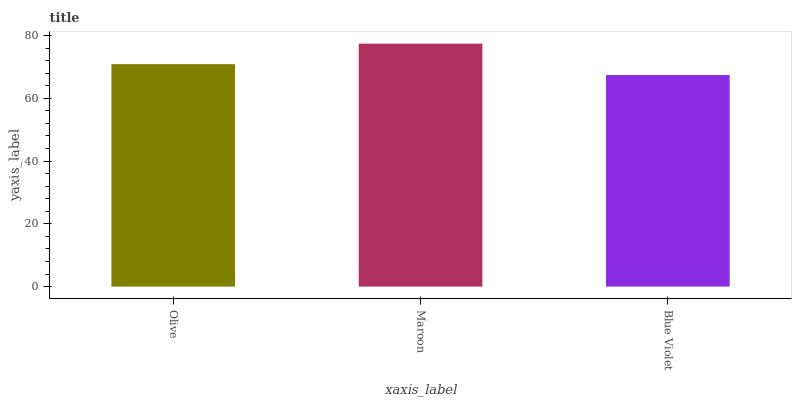Is Blue Violet the minimum?
Answer yes or no. Yes. Is Maroon the maximum?
Answer yes or no. Yes. Is Maroon the minimum?
Answer yes or no. No. Is Blue Violet the maximum?
Answer yes or no. No. Is Maroon greater than Blue Violet?
Answer yes or no. Yes. Is Blue Violet less than Maroon?
Answer yes or no. Yes. Is Blue Violet greater than Maroon?
Answer yes or no. No. Is Maroon less than Blue Violet?
Answer yes or no. No. Is Olive the high median?
Answer yes or no. Yes. Is Olive the low median?
Answer yes or no. Yes. Is Blue Violet the high median?
Answer yes or no. No. Is Maroon the low median?
Answer yes or no. No. 